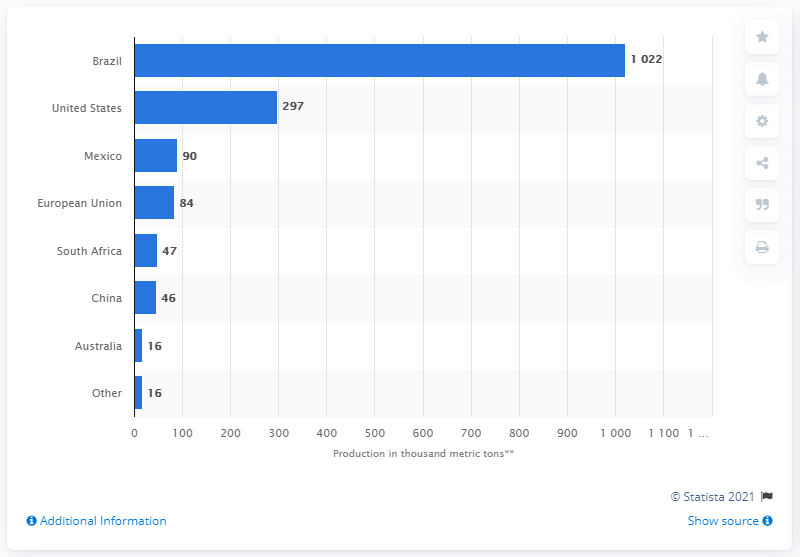Outline some significant characteristics in this image. In the 2019/2020 season, Brazil was the leading global producer of orange juice. 